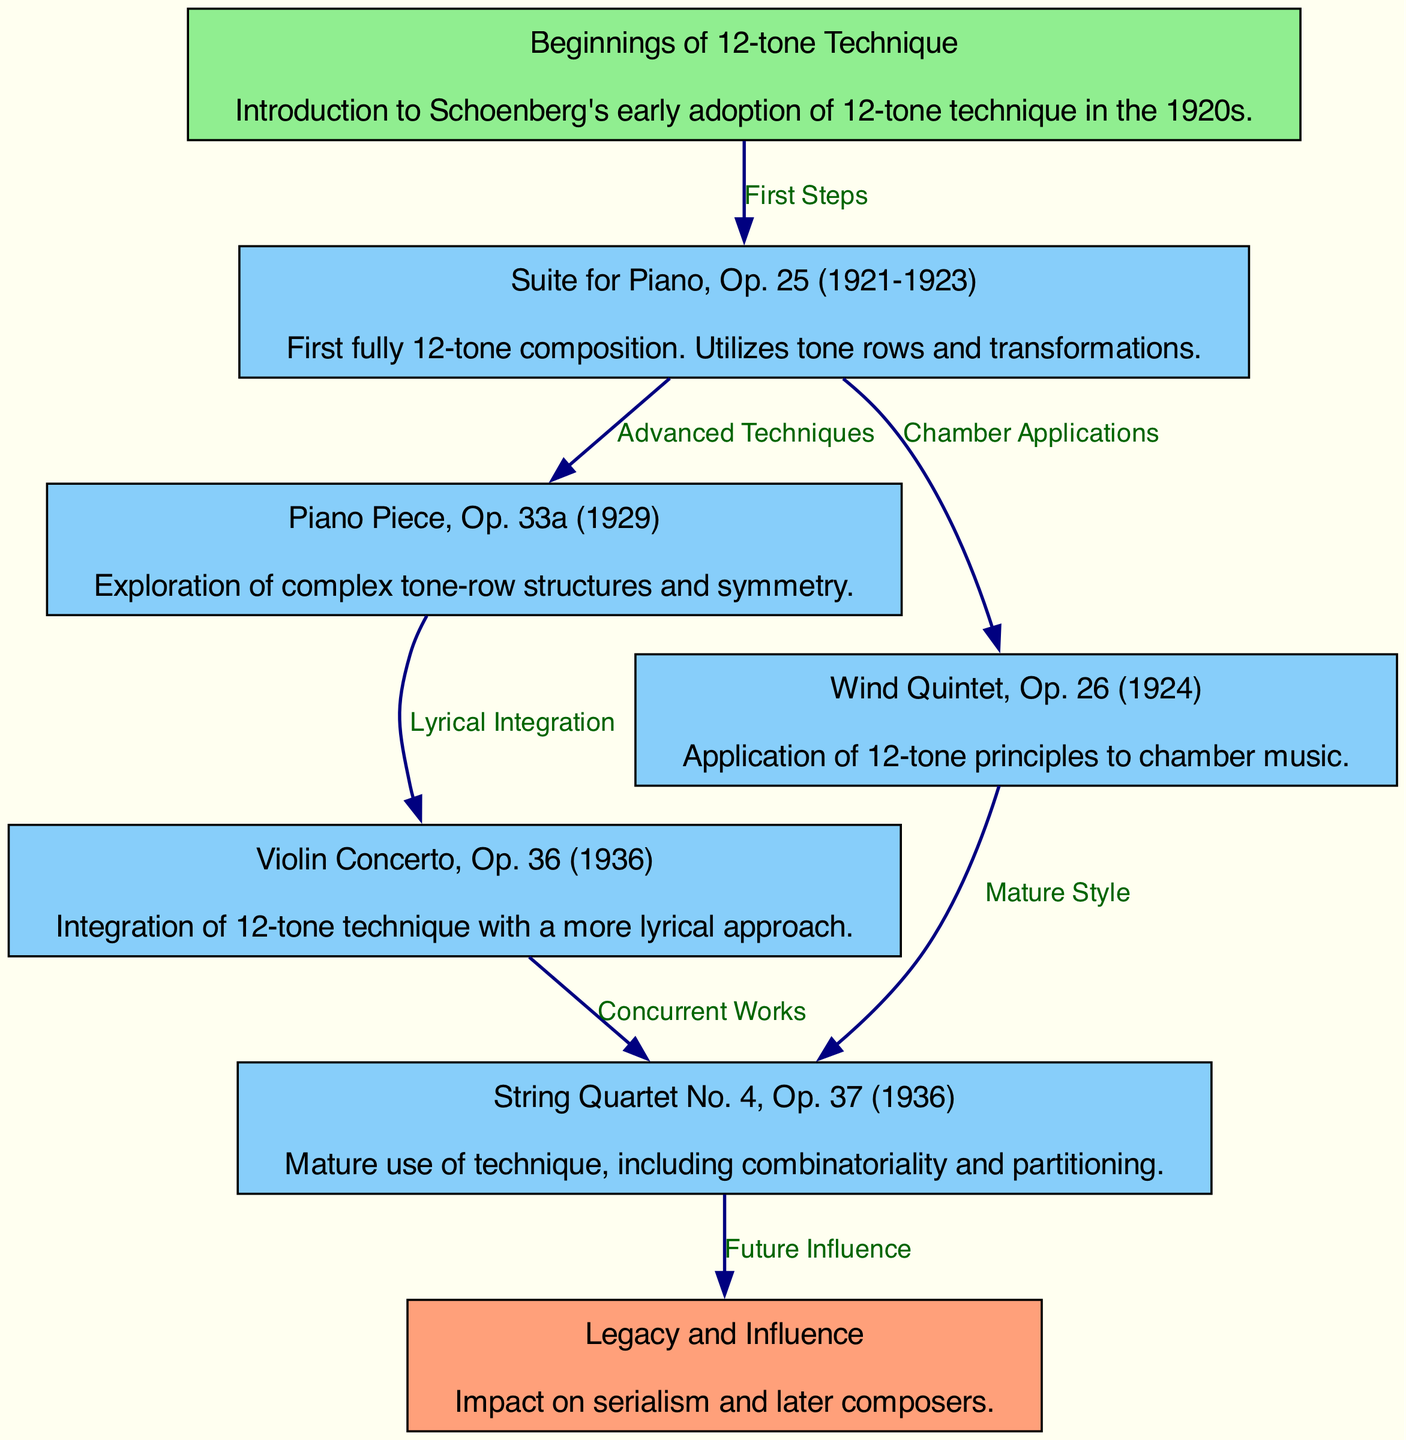What is the first fully 12-tone composition by Schoenberg? The diagram specifically states that the "Suite for Piano, Op. 25" is the first fully 12-tone composition, as highlighted under that node.
Answer: Suite for Piano, Op. 25 How many major works are analyzed in this diagram? The diagram features six nodes representing major works, including "Beginnings of 12-tone Technique" and "Legacy and Influence." Thus, by excluding the background nodes, there are five major works detailed.
Answer: five What correlation is indicated between the "Suite for Piano, Op. 25" and the "Wind Quintet, Op. 26"? The diagram shows an edge labeled "Chamber Applications" which connects these two works, indicating that the "Suite for Piano, Op. 25" influenced Schoenberg's approach to chamber music as seen in the "Wind Quintet, Op. 26."
Answer: Chamber Applications What does the edge labeled "Future Influence" connect? The edge labeled "Future Influence" connects the "String Quartet No. 4, Op. 37" to the "Legacy and Influence" node, indicating that this work significantly contributes to Schoenberg's lasting impact on later music.
Answer: Legacy and Influence Which composition explores complex tone-row structures and symmetry? The node labeled "Piano Piece, Op. 33a" explicitly states that it engages with complex tone-row structures and symmetry in its description.
Answer: Piano Piece, Op. 33a How are the "Violin Concerto, Op. 36" and "String Quartet No. 4, Op. 37" related in terms of timing? The edge between the "Violin Concerto, Op. 36" and "String Quartet No. 4, Op. 37" is labeled "Concurrent Works," suggesting that these compositions were created around the same timeframe, showing Schoenberg's evolving use of 12-tone techniques.
Answer: Concurrent Works What technique is maturely used in the "String Quartet No. 4, Op. 37"? The description associated with the "String Quartet No. 4, Op. 37" mentions mature use of techniques including combinatoriality and partitioning, emphasizing its advanced exploration of 12-tone techniques.
Answer: combinatoriality and partitioning 